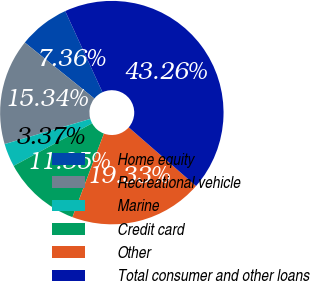<chart> <loc_0><loc_0><loc_500><loc_500><pie_chart><fcel>Home equity<fcel>Recreational vehicle<fcel>Marine<fcel>Credit card<fcel>Other<fcel>Total consumer and other loans<nl><fcel>7.36%<fcel>15.34%<fcel>3.37%<fcel>11.35%<fcel>19.33%<fcel>43.27%<nl></chart> 